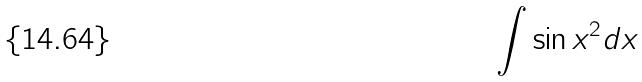Convert formula to latex. <formula><loc_0><loc_0><loc_500><loc_500>\int \sin x ^ { 2 } d x</formula> 